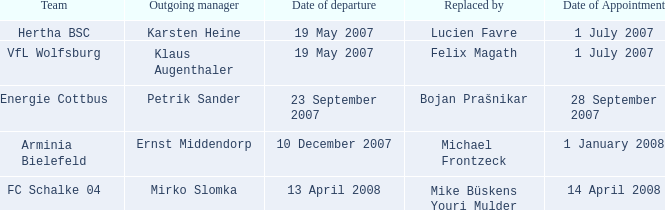When is the appointment date for outgoing manager Petrik Sander? 28 September 2007. 